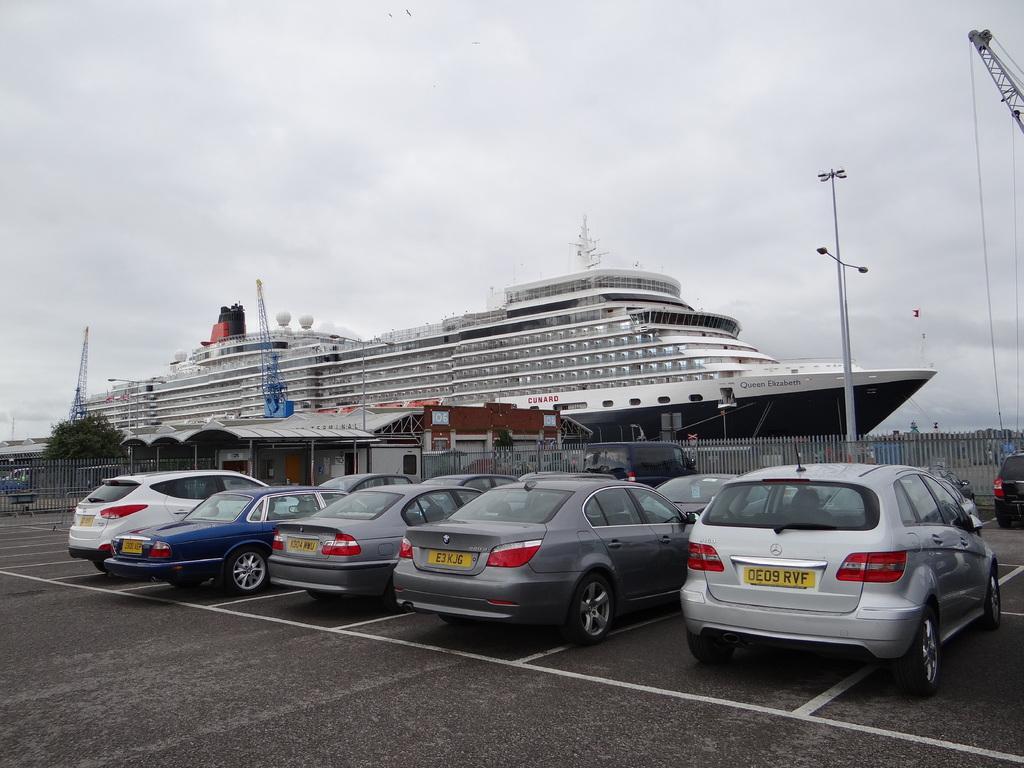Could you give a brief overview of what you see in this image? In this picture in the center there are cars on the road. In the background there is a fence. There is a tree. There is a pole. There is a ship and there are stands and there are tents and the sky is cloudy. 